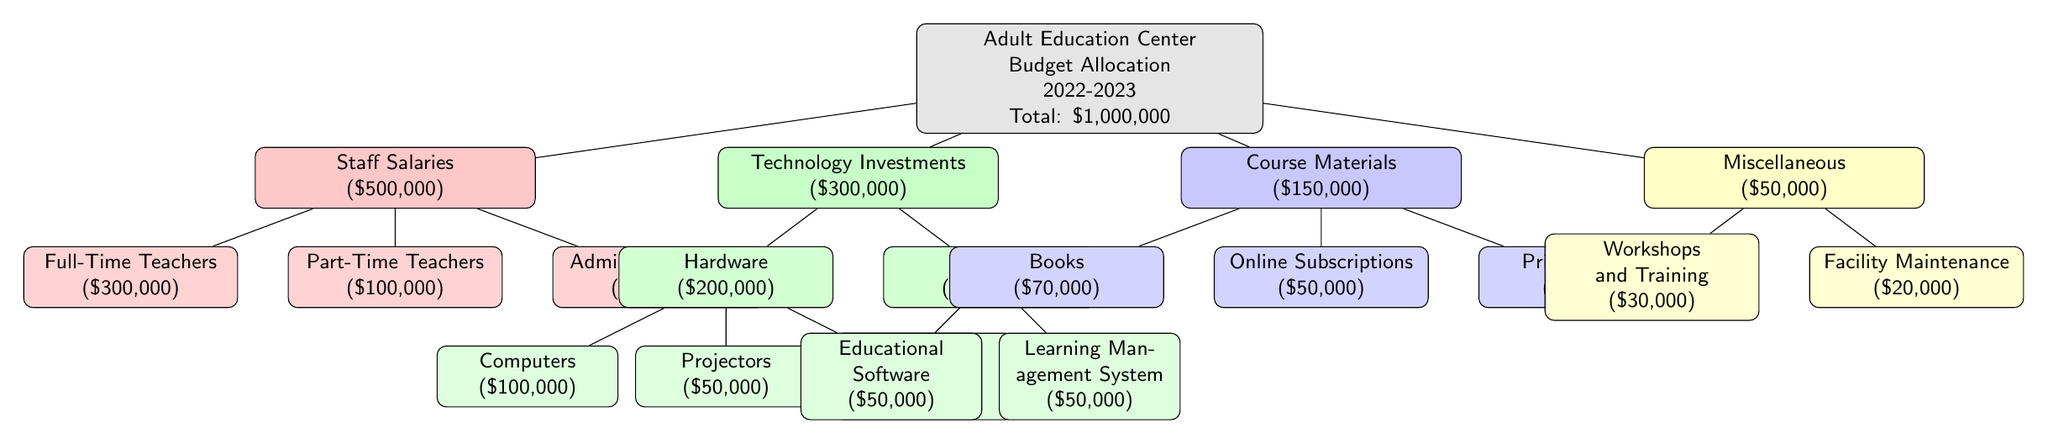What is the total budget for the Adult Education Center in 2022-2023? The diagram states that the total budget allocation for the Adult Education Center for the fiscal year 2022-2023 is shown at the top of the primary node, with the amount being one million dollars.
Answer: One million dollars How much is allocated for staff salaries? Within the diagram, staff salaries are clearly listed as a category under the budget allocation, indicating that five hundred thousand dollars are assigned for this purpose.
Answer: Five hundred thousand dollars What portion of the technology investments is designated for hardware? The section of technology investments indicated that hardware has a budget allocation of two hundred thousand dollars. This can be seen from the child node connected to the technology investments node.
Answer: Two hundred thousand dollars Which category has the smallest allocation? By reviewing all the main categories listed in the diagram, it becomes evident that the miscellaneous category has an allocation of fifty thousand dollars, which is less than any other category.
Answer: Miscellaneous What are the total amounts allocated to full-time teachers and administrative staff combined? The total for full-time teachers is three hundred thousand dollars, and administrative staff have one hundred thousand dollars. Adding these together gives four hundred thousand dollars, showing the combined allocation from these two subcategories under staff salaries.
Answer: Four hundred thousand dollars How many child nodes are there under technology investments? Under the technology investments node, there are five child nodes depicted in the diagram for various technology-related allocations. This includes hardware, software, and their respective subcategories.
Answer: Five What is the allocation for online subscriptions? The diagram indicates that online subscriptions fall under the course materials category, with a specific allocation of fifty thousand dollars for this item, as noted in the child node.
Answer: Fifty thousand dollars Which item has the highest allocation under course materials? According to the course materials breakdown in the diagram, books are allocated seventy thousand dollars, which is the highest specific item allocation within that category.
Answer: Books How much funding is designated for workshops and training? Within the miscellaneous category, workshops and training are allotted thirty thousand dollars as indicated in the corresponding child node, clearly depicting this specific allocation.
Answer: Thirty thousand dollars 